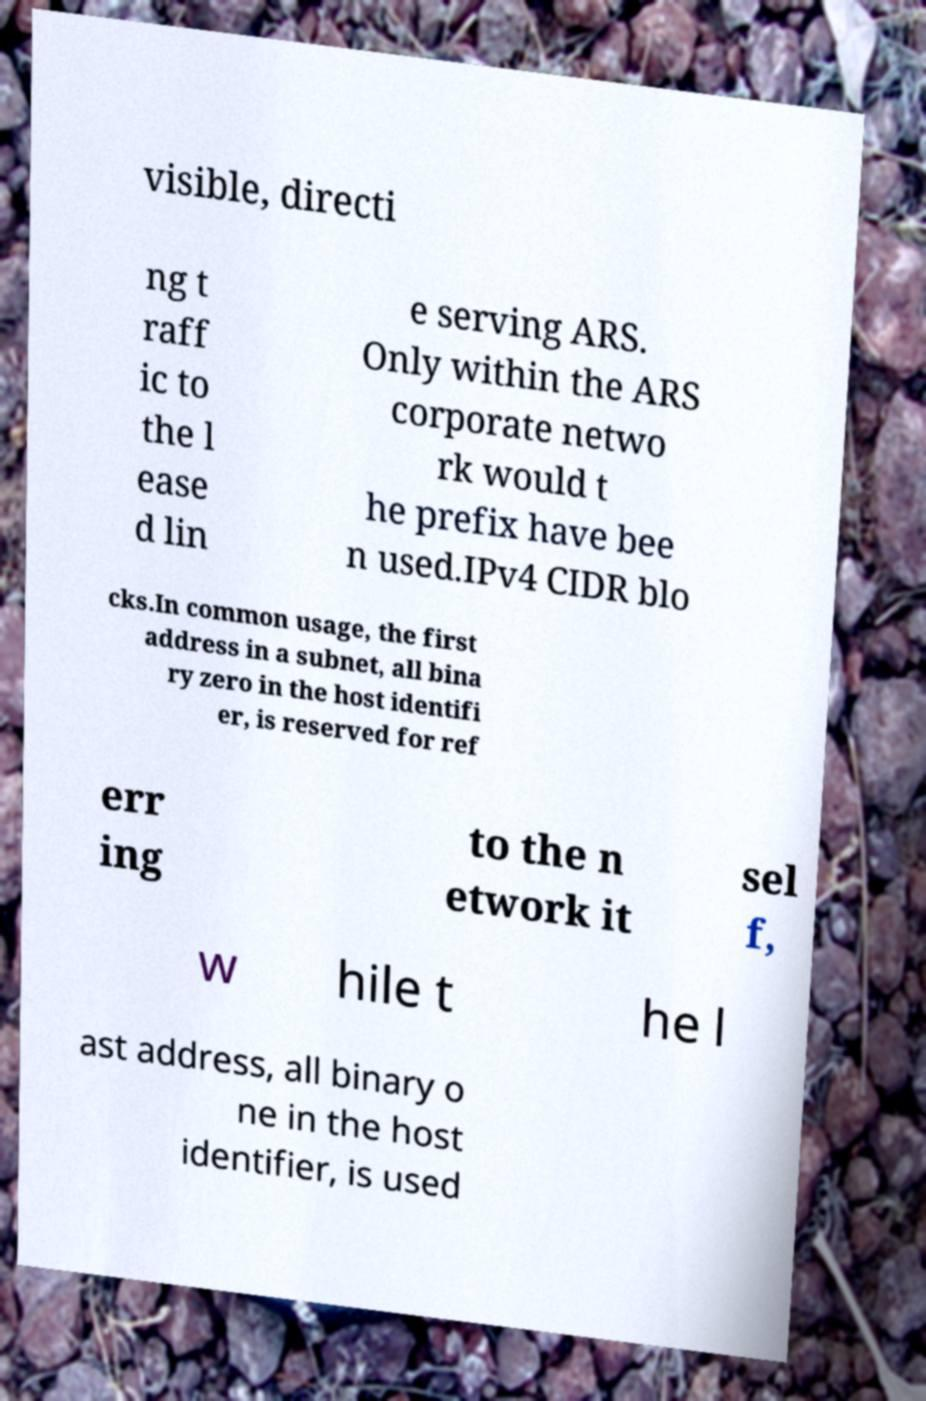Please identify and transcribe the text found in this image. visible, directi ng t raff ic to the l ease d lin e serving ARS. Only within the ARS corporate netwo rk would t he prefix have bee n used.IPv4 CIDR blo cks.In common usage, the first address in a subnet, all bina ry zero in the host identifi er, is reserved for ref err ing to the n etwork it sel f, w hile t he l ast address, all binary o ne in the host identifier, is used 